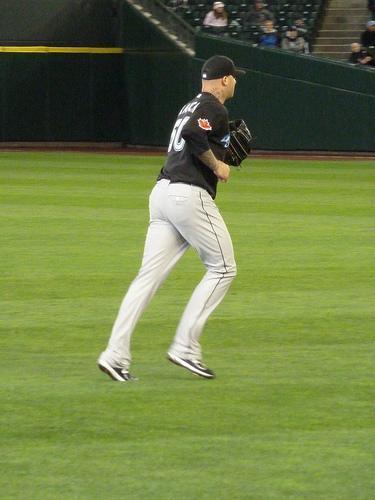How many players are shown?
Give a very brief answer. 1. 